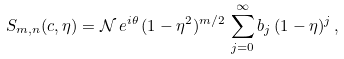Convert formula to latex. <formula><loc_0><loc_0><loc_500><loc_500>S _ { m , n } ( c , \eta ) = \mathcal { N } \, e ^ { i \theta } \, ( 1 - \eta ^ { 2 } ) ^ { m / 2 } \, \sum _ { j = 0 } ^ { \infty } b _ { j } \, ( 1 - \eta ) ^ { j } \, ,</formula> 